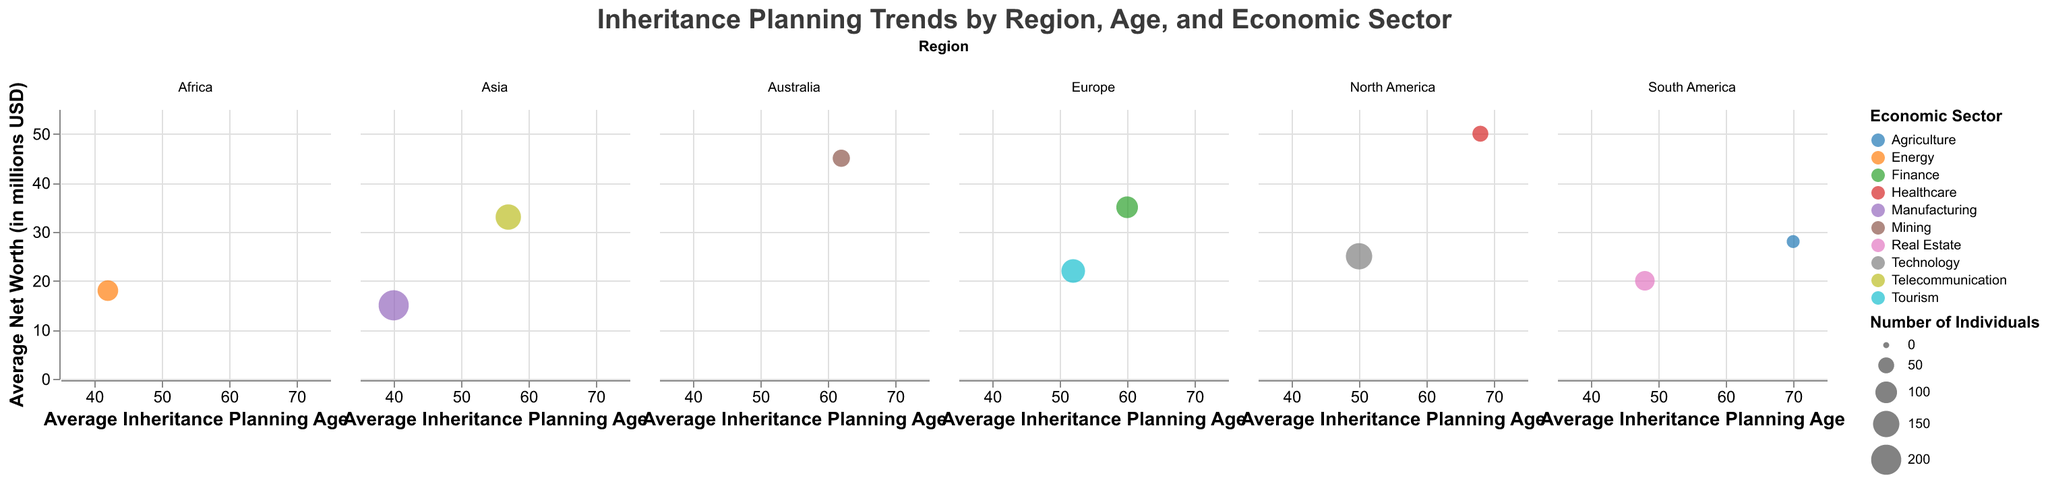What's the average inheritance planning age for individuals in the Finance sector? The Finance sector is found in the Europe region. According to the data, the average inheritance planning age for individuals in the Finance sector is 60.
Answer: 60 How does the average net worth of high-net-worth individuals in North America's Technology sector compare to those in South America's Real Estate sector? For North America's Technology sector, the average net worth is 25 million USD, while for South America's Real Estate sector, it is 20 million USD. Therefore, individuals in North America's Technology sector have a higher average net worth.
Answer: 25 > 20 Which age group in the Europe region has the highest average net worth? In the Europe region, there are two data points: one for the 55-64 age group in the Finance sector with an average net worth of 35 million USD and another for the 45-54 age group in the Tourism sector with an average net worth of 22 million USD. The highest average net worth is therefore found in the 55-64 age group in the Finance sector.
Answer: 55-64 What is the economic sector with the highest average inheritance planning age, and in which region is it located? The highest average inheritance planning age is 70 years, found in South America's Agriculture sector.
Answer: Agriculture in South America Identify the range of average inheritance planning ages for individuals in the Asia region. In Asia, the Manufacturing sector has an average inheritance planning age of 40 years, and the Telecommunication sector has an average inheritance planning age of 57 years. Thus, the range is from 40 to 57 years.
Answer: 40-57 How many individuals are represented in the data point with the highest average net worth in North America? The highest average net worth in North America is found in the Healthcare sector, with an average net worth of 50 million USD. This data point represents 50 individuals.
Answer: 50 Compare the average inheritance planning ages between individuals in Africa's Energy sector and North America's Technology sector. Africa's Energy sector has an average inheritance planning age of 42 years, while North America's Technology sector has an average inheritance planning age of 50 years. North America's Technology sector has a higher average inheritance planning age.
Answer: 50 > 42 If you sum up the number of individuals from the Asia and Australia regions, what is the total? In Asia, there are 200 individuals in Manufacturing and 140 in Telecommunication, totaling 340. Australia has 60 individuals in Mining. Summing these gives 340 + 60 = 400 individuals.
Answer: 400 Which region contains the most economic sectors according to the data? In the Europe region, there are two economic sectors represented: Finance and Tourism. No other region has more than two sectors represented.
Answer: Europe What is the difference in the average net worth between individuals in the North American Healthcare sector and the Asian Telecommunication sector? The North American Healthcare sector has an average net worth of 50 million USD, and the Asian Telecommunication sector has an average net worth of 33 million USD. The difference is 50 - 33 = 17 million USD.
Answer: 17 million USD 